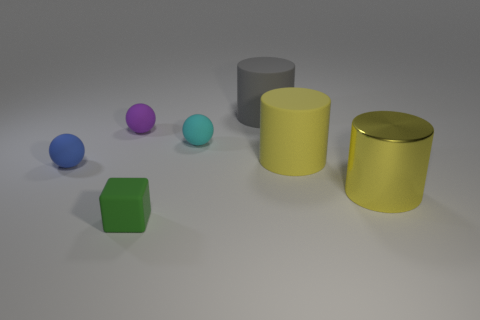What shape is the object that is on the left side of the shiny cylinder and in front of the small blue matte ball?
Give a very brief answer. Cube. What shape is the thing to the left of the sphere that is behind the cyan rubber thing?
Ensure brevity in your answer.  Sphere. Is the green rubber thing the same shape as the yellow shiny object?
Your answer should be compact. No. There is another large cylinder that is the same color as the big shiny cylinder; what is its material?
Keep it short and to the point. Rubber. Does the shiny object have the same color as the cube?
Your response must be concise. No. How many small matte spheres are to the right of the cylinder in front of the big yellow cylinder to the left of the yellow metal thing?
Ensure brevity in your answer.  0. There is a tiny purple thing that is made of the same material as the cyan ball; what is its shape?
Your response must be concise. Sphere. There is a large cylinder to the right of the rubber cylinder on the right side of the big rubber cylinder behind the purple object; what is its material?
Make the answer very short. Metal. How many objects are either objects behind the cube or balls?
Offer a terse response. 6. What number of other things are the same shape as the small cyan thing?
Offer a very short reply. 2. 